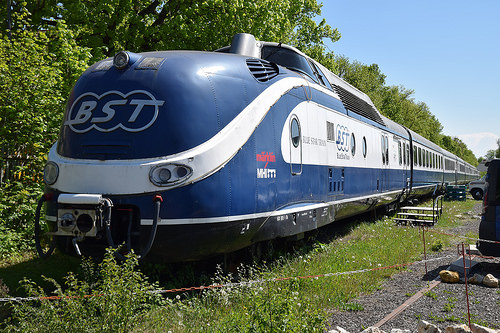<image>
Is the gravel under the train? No. The gravel is not positioned under the train. The vertical relationship between these objects is different. 